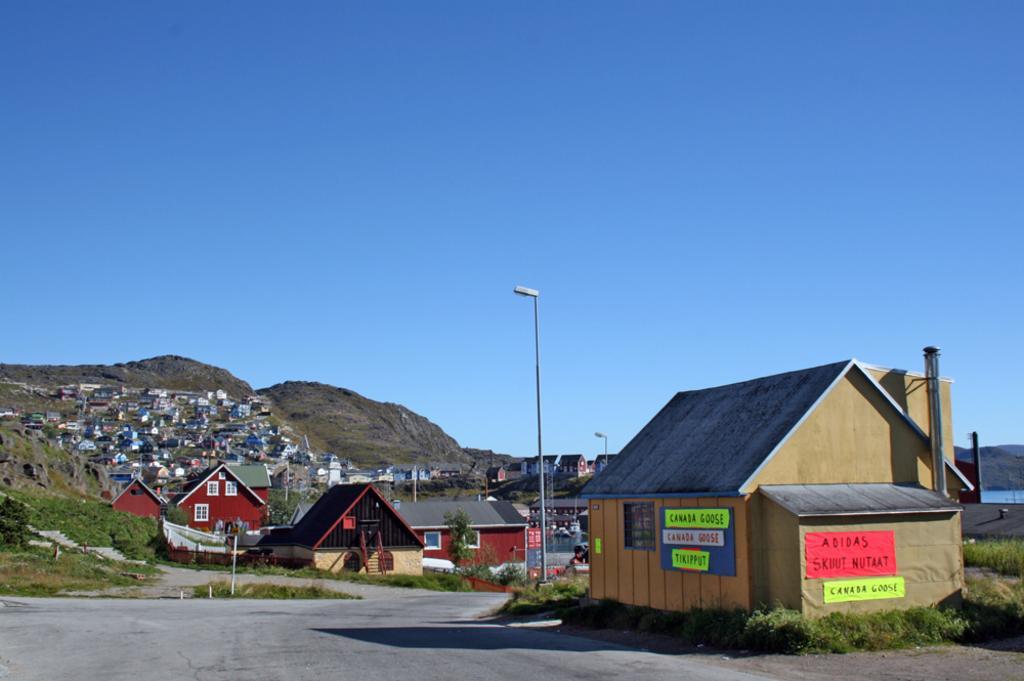Please provide a concise description of this image. In this image we can see houses, a light pole, there are mountains, plants, grass, also we can see the lake and the sky. 